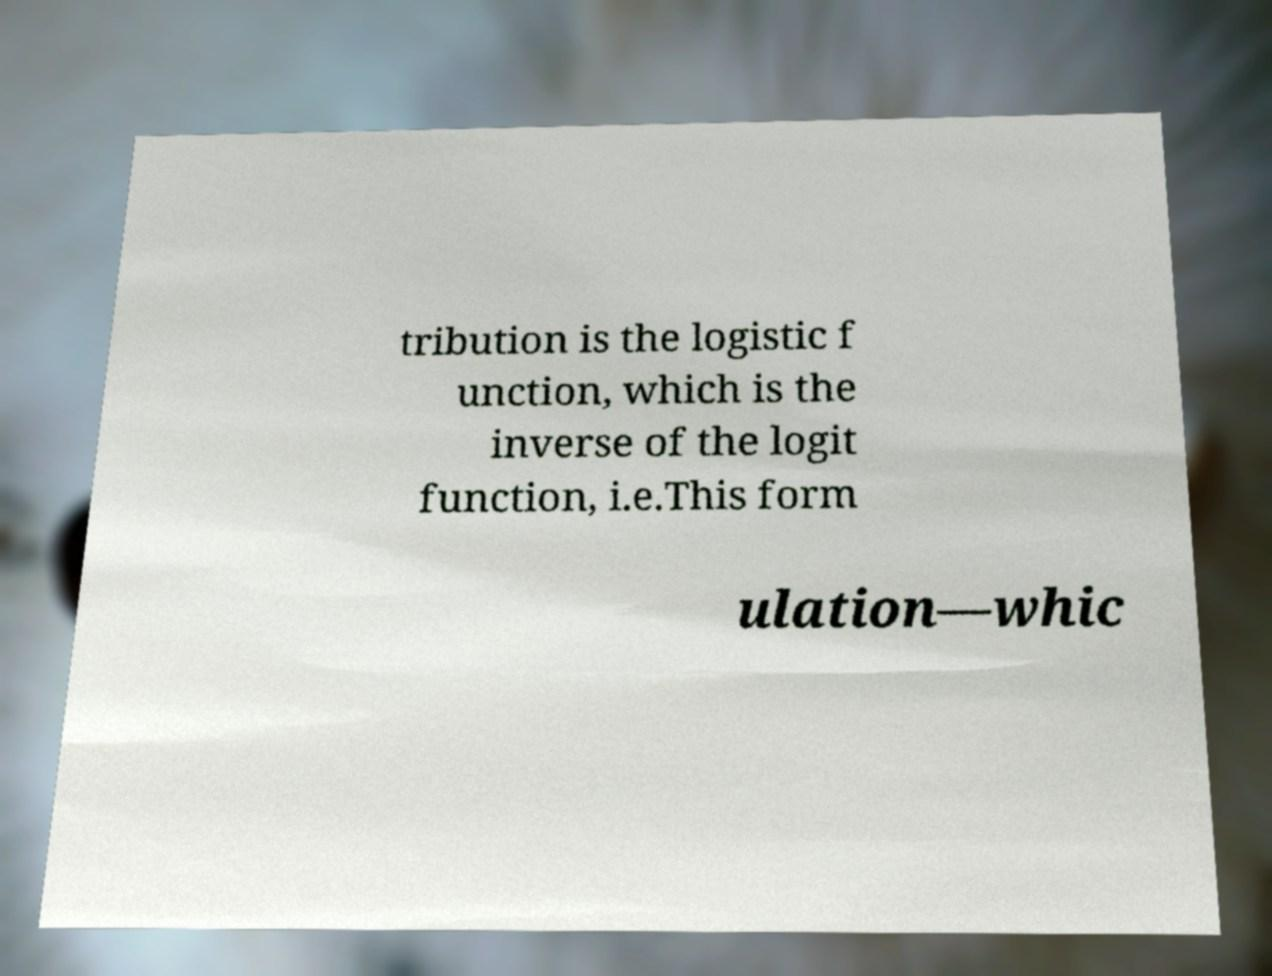For documentation purposes, I need the text within this image transcribed. Could you provide that? tribution is the logistic f unction, which is the inverse of the logit function, i.e.This form ulation—whic 